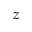<formula> <loc_0><loc_0><loc_500><loc_500>z</formula> 